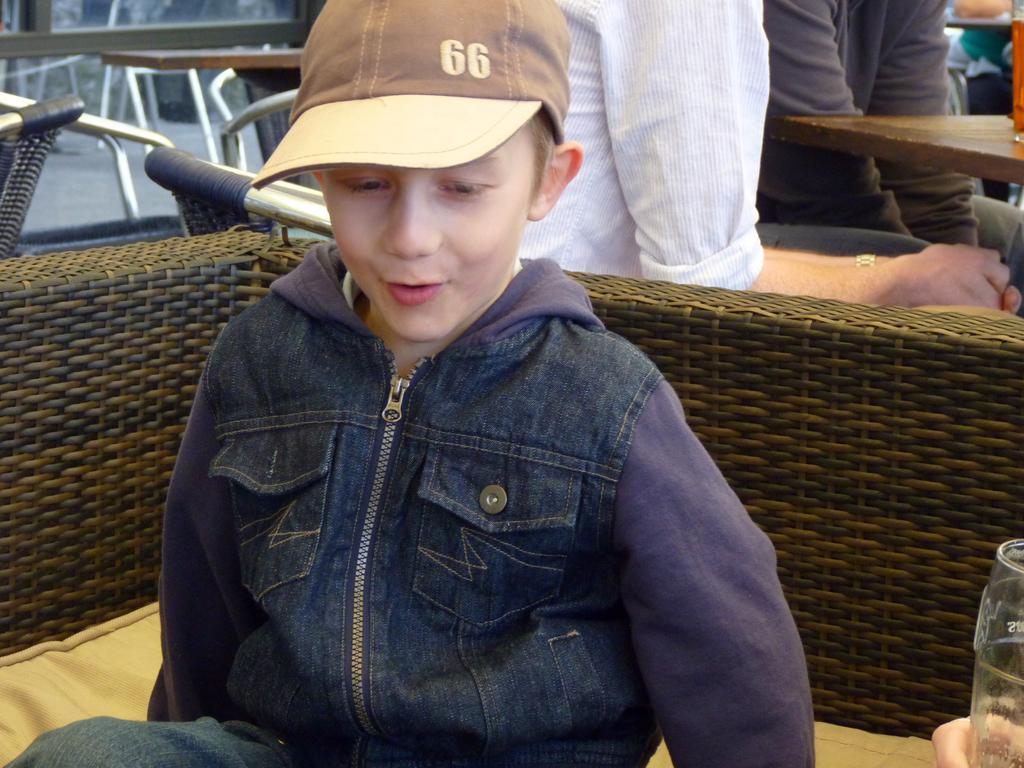How would you summarize this image in a sentence or two? In this image I can see a boy is sitting in the front, I can see he is wearing a jacket, jeans and a cap. On the right side of this image I can see a glass in a person's hand. In the background I can see a table, few people and on the left side I can see one more table and few empty chairs. 